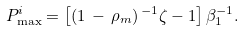<formula> <loc_0><loc_0><loc_500><loc_500>P _ { \max } ^ { i } = \left [ ( 1 \, - \, \rho _ { m } ) ^ { \, - 1 } \zeta - 1 \right ] \beta _ { 1 } ^ { - 1 } .</formula> 